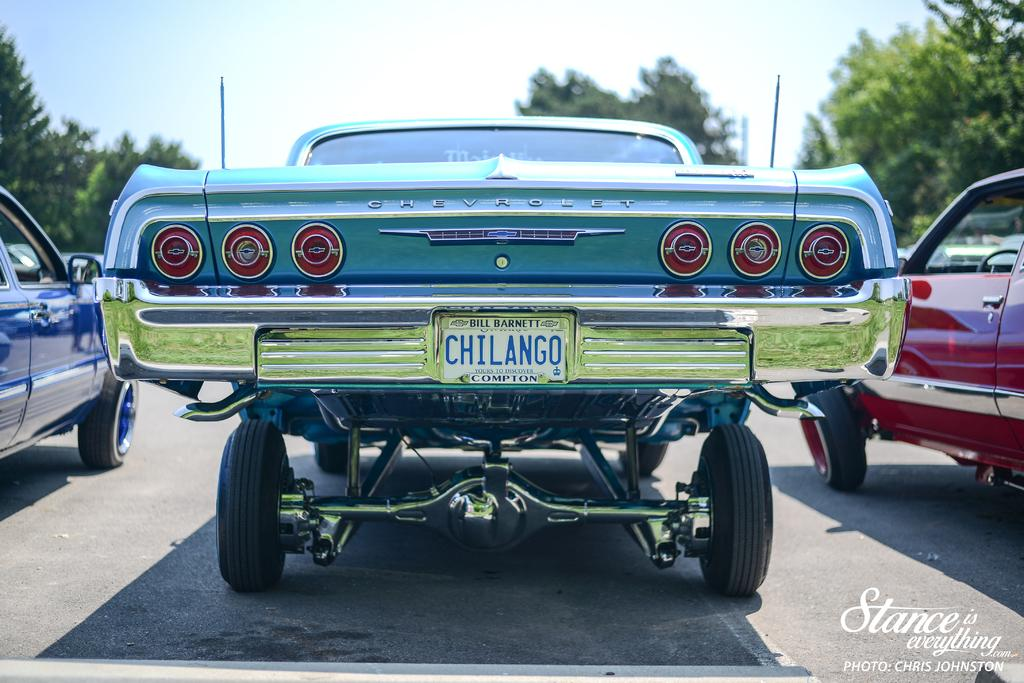How many vehicles can be seen in the image? There are three vehicles in the image. Where are the vehicles located? The vehicles are parked on the road. What is visible at the top of the image? The sky is visible at the top of the image. Is there any text present in the image? Yes, there is text in the bottom right corner of the image. What flavor of account is mentioned in the text at the bottom right corner of the image? There is no mention of an account or any flavor in the image. The text in the bottom right corner is unrelated to accounts or flavors. 